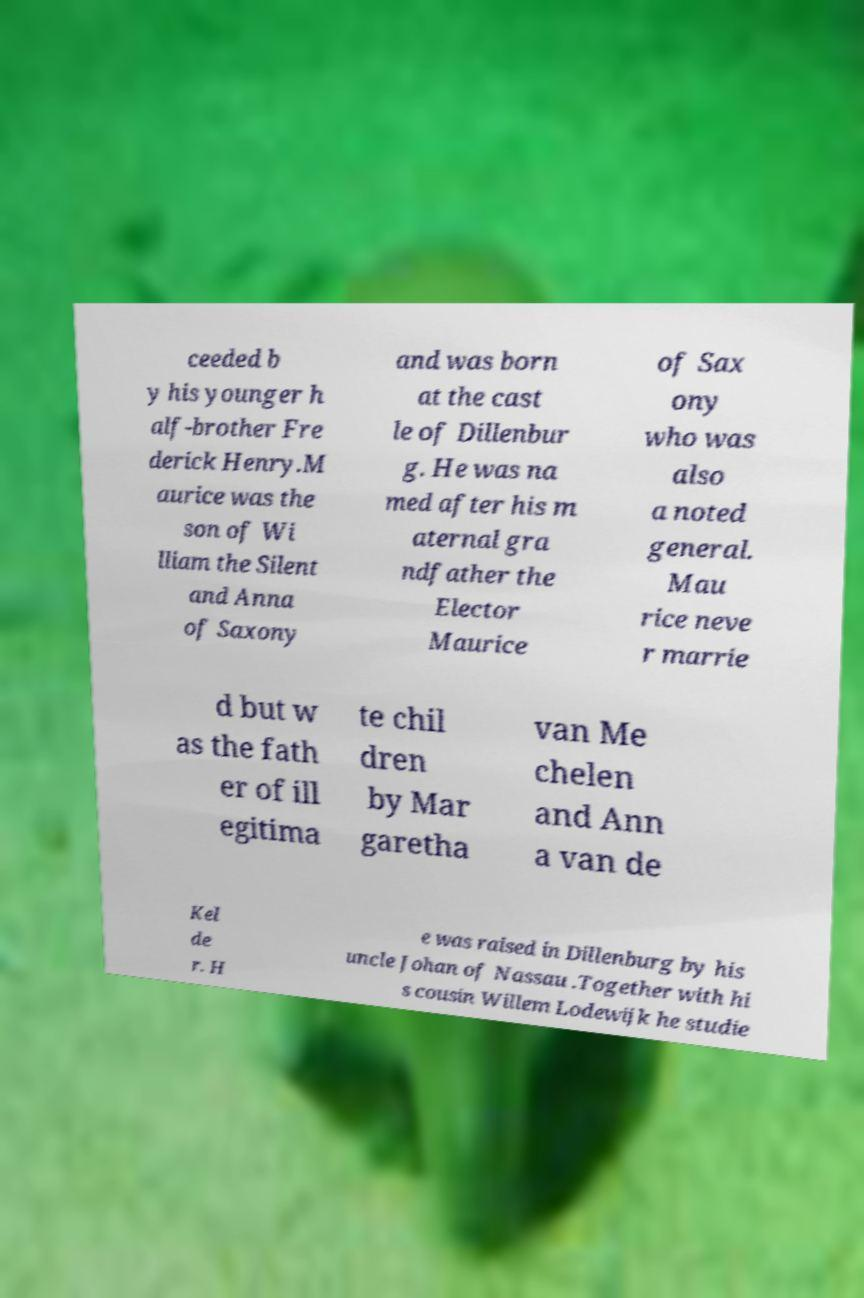I need the written content from this picture converted into text. Can you do that? ceeded b y his younger h alf-brother Fre derick Henry.M aurice was the son of Wi lliam the Silent and Anna of Saxony and was born at the cast le of Dillenbur g. He was na med after his m aternal gra ndfather the Elector Maurice of Sax ony who was also a noted general. Mau rice neve r marrie d but w as the fath er of ill egitima te chil dren by Mar garetha van Me chelen and Ann a van de Kel de r. H e was raised in Dillenburg by his uncle Johan of Nassau .Together with hi s cousin Willem Lodewijk he studie 